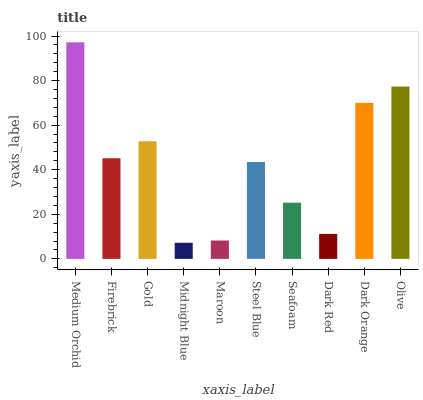Is Midnight Blue the minimum?
Answer yes or no. Yes. Is Medium Orchid the maximum?
Answer yes or no. Yes. Is Firebrick the minimum?
Answer yes or no. No. Is Firebrick the maximum?
Answer yes or no. No. Is Medium Orchid greater than Firebrick?
Answer yes or no. Yes. Is Firebrick less than Medium Orchid?
Answer yes or no. Yes. Is Firebrick greater than Medium Orchid?
Answer yes or no. No. Is Medium Orchid less than Firebrick?
Answer yes or no. No. Is Firebrick the high median?
Answer yes or no. Yes. Is Steel Blue the low median?
Answer yes or no. Yes. Is Medium Orchid the high median?
Answer yes or no. No. Is Dark Orange the low median?
Answer yes or no. No. 